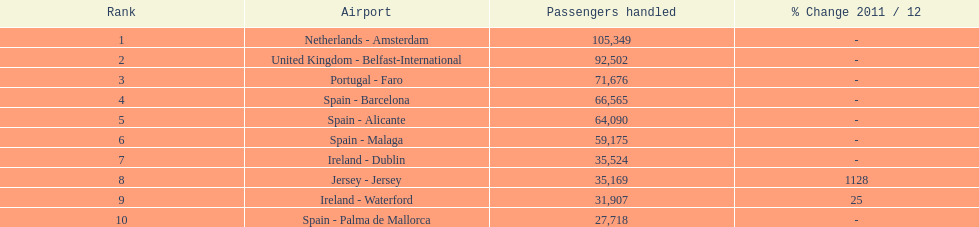How many airports are cataloged? 10. 